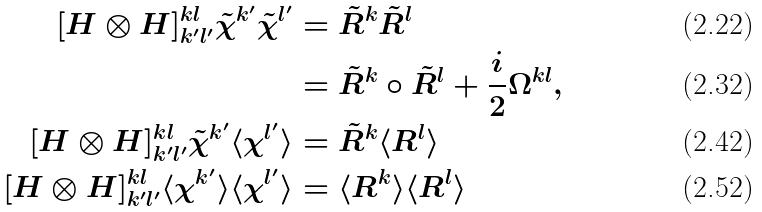<formula> <loc_0><loc_0><loc_500><loc_500>[ H \otimes H ] ^ { k l } _ { k ^ { \prime } l ^ { \prime } } \tilde { \chi } ^ { k ^ { \prime } } \tilde { \chi } ^ { l ^ { \prime } } & = \tilde { R } ^ { k } \tilde { R } ^ { l } \\ & = \tilde { R } ^ { k } \circ \tilde { R } ^ { l } + \frac { i } { 2 } \Omega ^ { k l } , \\ [ H \otimes H ] ^ { k l } _ { k ^ { \prime } l ^ { \prime } } \tilde { \chi } ^ { k ^ { \prime } } \langle \chi ^ { l ^ { \prime } } \rangle & = \tilde { R } ^ { k } \langle R ^ { l } \rangle \\ [ H \otimes H ] ^ { k l } _ { k ^ { \prime } l ^ { \prime } } \langle \chi ^ { k ^ { \prime } } \rangle \langle \chi ^ { l ^ { \prime } } \rangle & = \langle R ^ { k } \rangle \langle R ^ { l } \rangle</formula> 